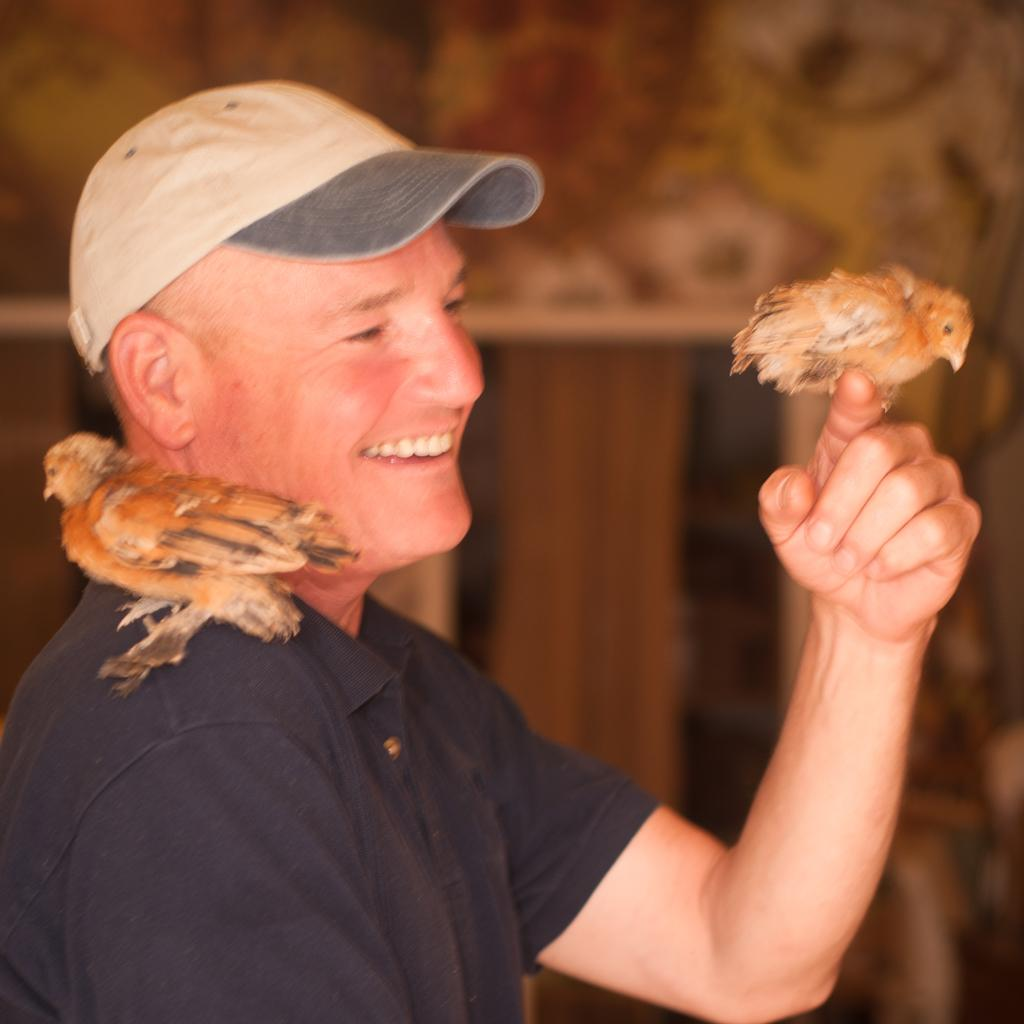Who is the main subject in the foreground of the image? There is a man in the foreground of the image. What is the man wearing on his head? The man is wearing a cap. How many birds are present in the image? There are two birds in the image. Where is one of the birds located in relation to the man? One bird is on the man's finger. Where is the other bird located in relation to the man? The other bird is on the man's shoulder. Can you describe the background of the image? The background of the image is blurry. What type of crow can be seen flying in the sky in the image? There is no crow or sky visible in the image. What is the aftermath of the event depicted in the image? There is no event depicted in the image, so it is not possible to determine the aftermath. 